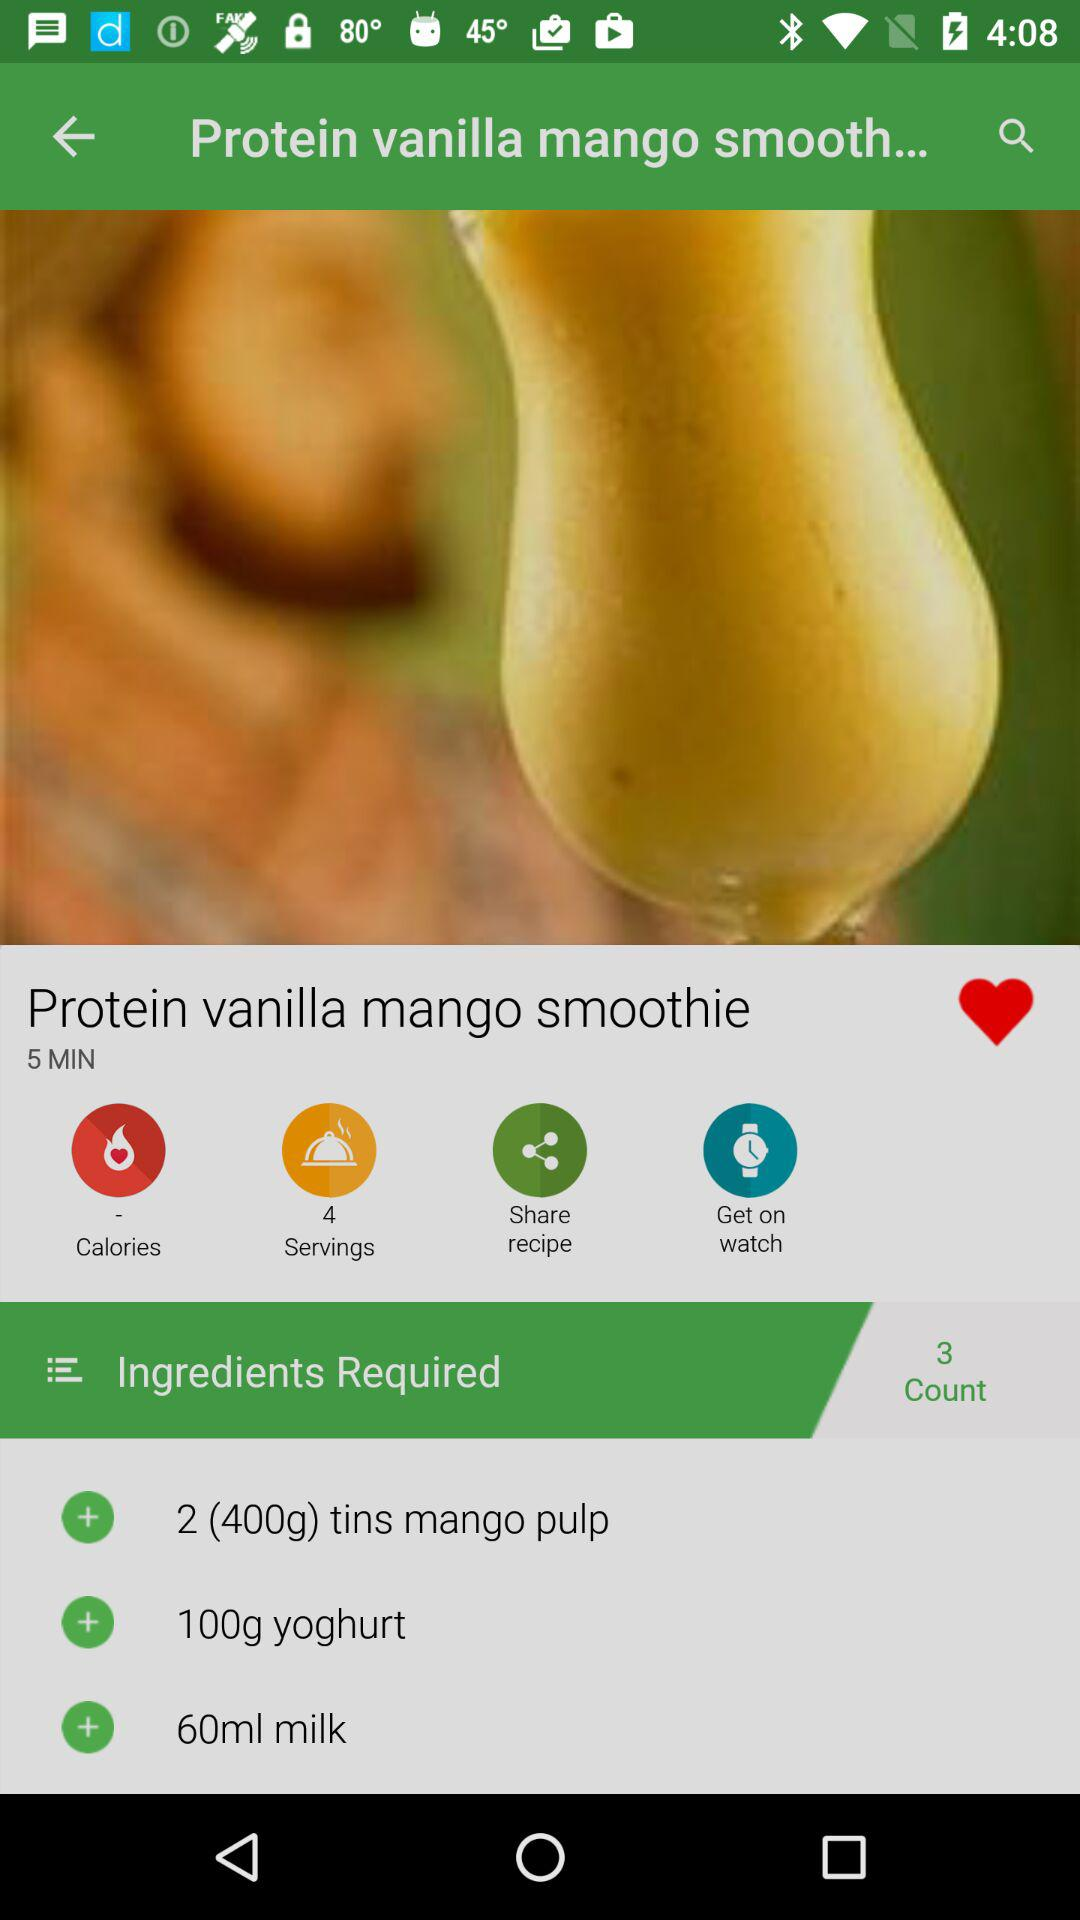What is the ingredient count for the smoothie? The ingredient count for the smoothie is 3. 